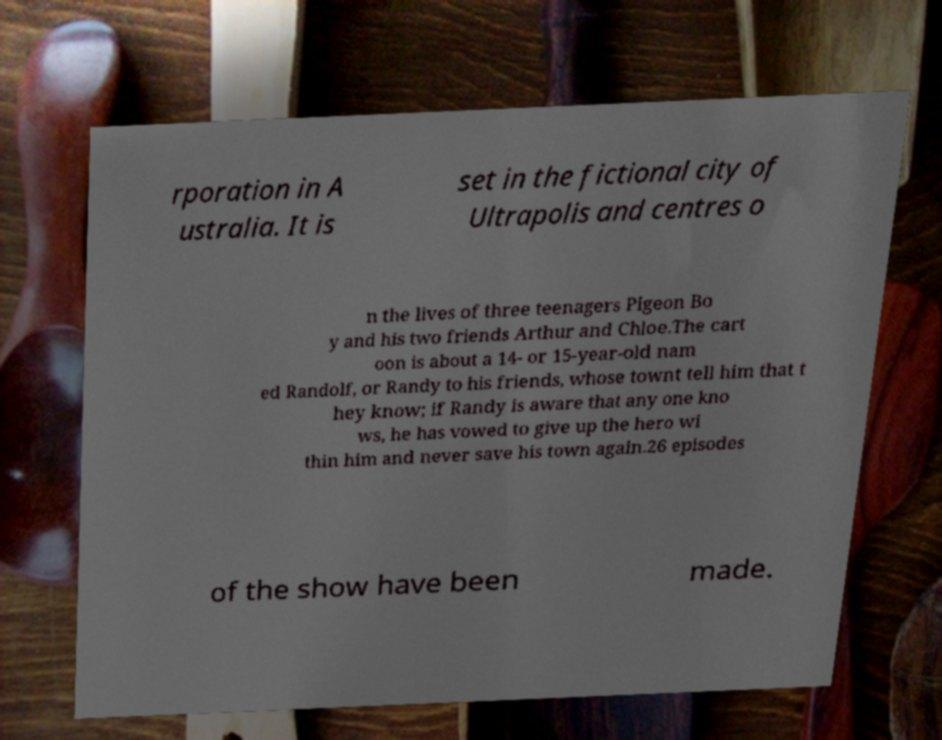I need the written content from this picture converted into text. Can you do that? rporation in A ustralia. It is set in the fictional city of Ultrapolis and centres o n the lives of three teenagers Pigeon Bo y and his two friends Arthur and Chloe.The cart oon is about a 14- or 15-year-old nam ed Randolf, or Randy to his friends, whose townt tell him that t hey know; if Randy is aware that any one kno ws, he has vowed to give up the hero wi thin him and never save his town again.26 episodes of the show have been made. 